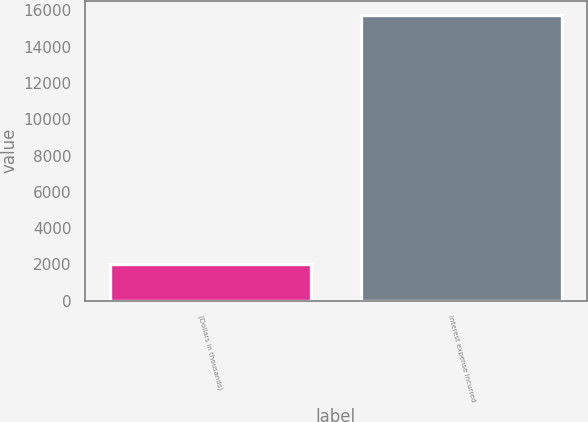Convert chart. <chart><loc_0><loc_0><loc_500><loc_500><bar_chart><fcel>(Dollars in thousands)<fcel>Interest expense incurred<nl><fcel>2014<fcel>15749<nl></chart> 